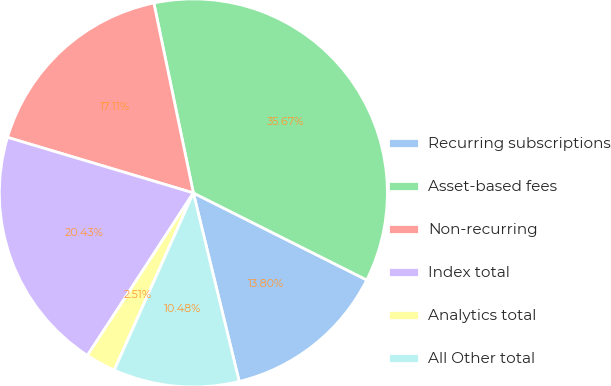Convert chart. <chart><loc_0><loc_0><loc_500><loc_500><pie_chart><fcel>Recurring subscriptions<fcel>Asset-based fees<fcel>Non-recurring<fcel>Index total<fcel>Analytics total<fcel>All Other total<nl><fcel>13.8%<fcel>35.67%<fcel>17.11%<fcel>20.43%<fcel>2.51%<fcel>10.48%<nl></chart> 